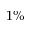<formula> <loc_0><loc_0><loc_500><loc_500>1 \%</formula> 